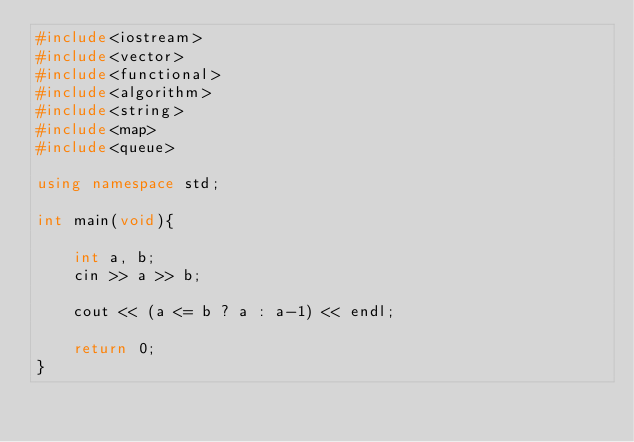Convert code to text. <code><loc_0><loc_0><loc_500><loc_500><_C++_>#include<iostream>
#include<vector>
#include<functional>
#include<algorithm>
#include<string>
#include<map>
#include<queue>

using namespace std;

int main(void){

    int a, b;
    cin >> a >> b;

    cout << (a <= b ? a : a-1) << endl;

    return 0;
}</code> 